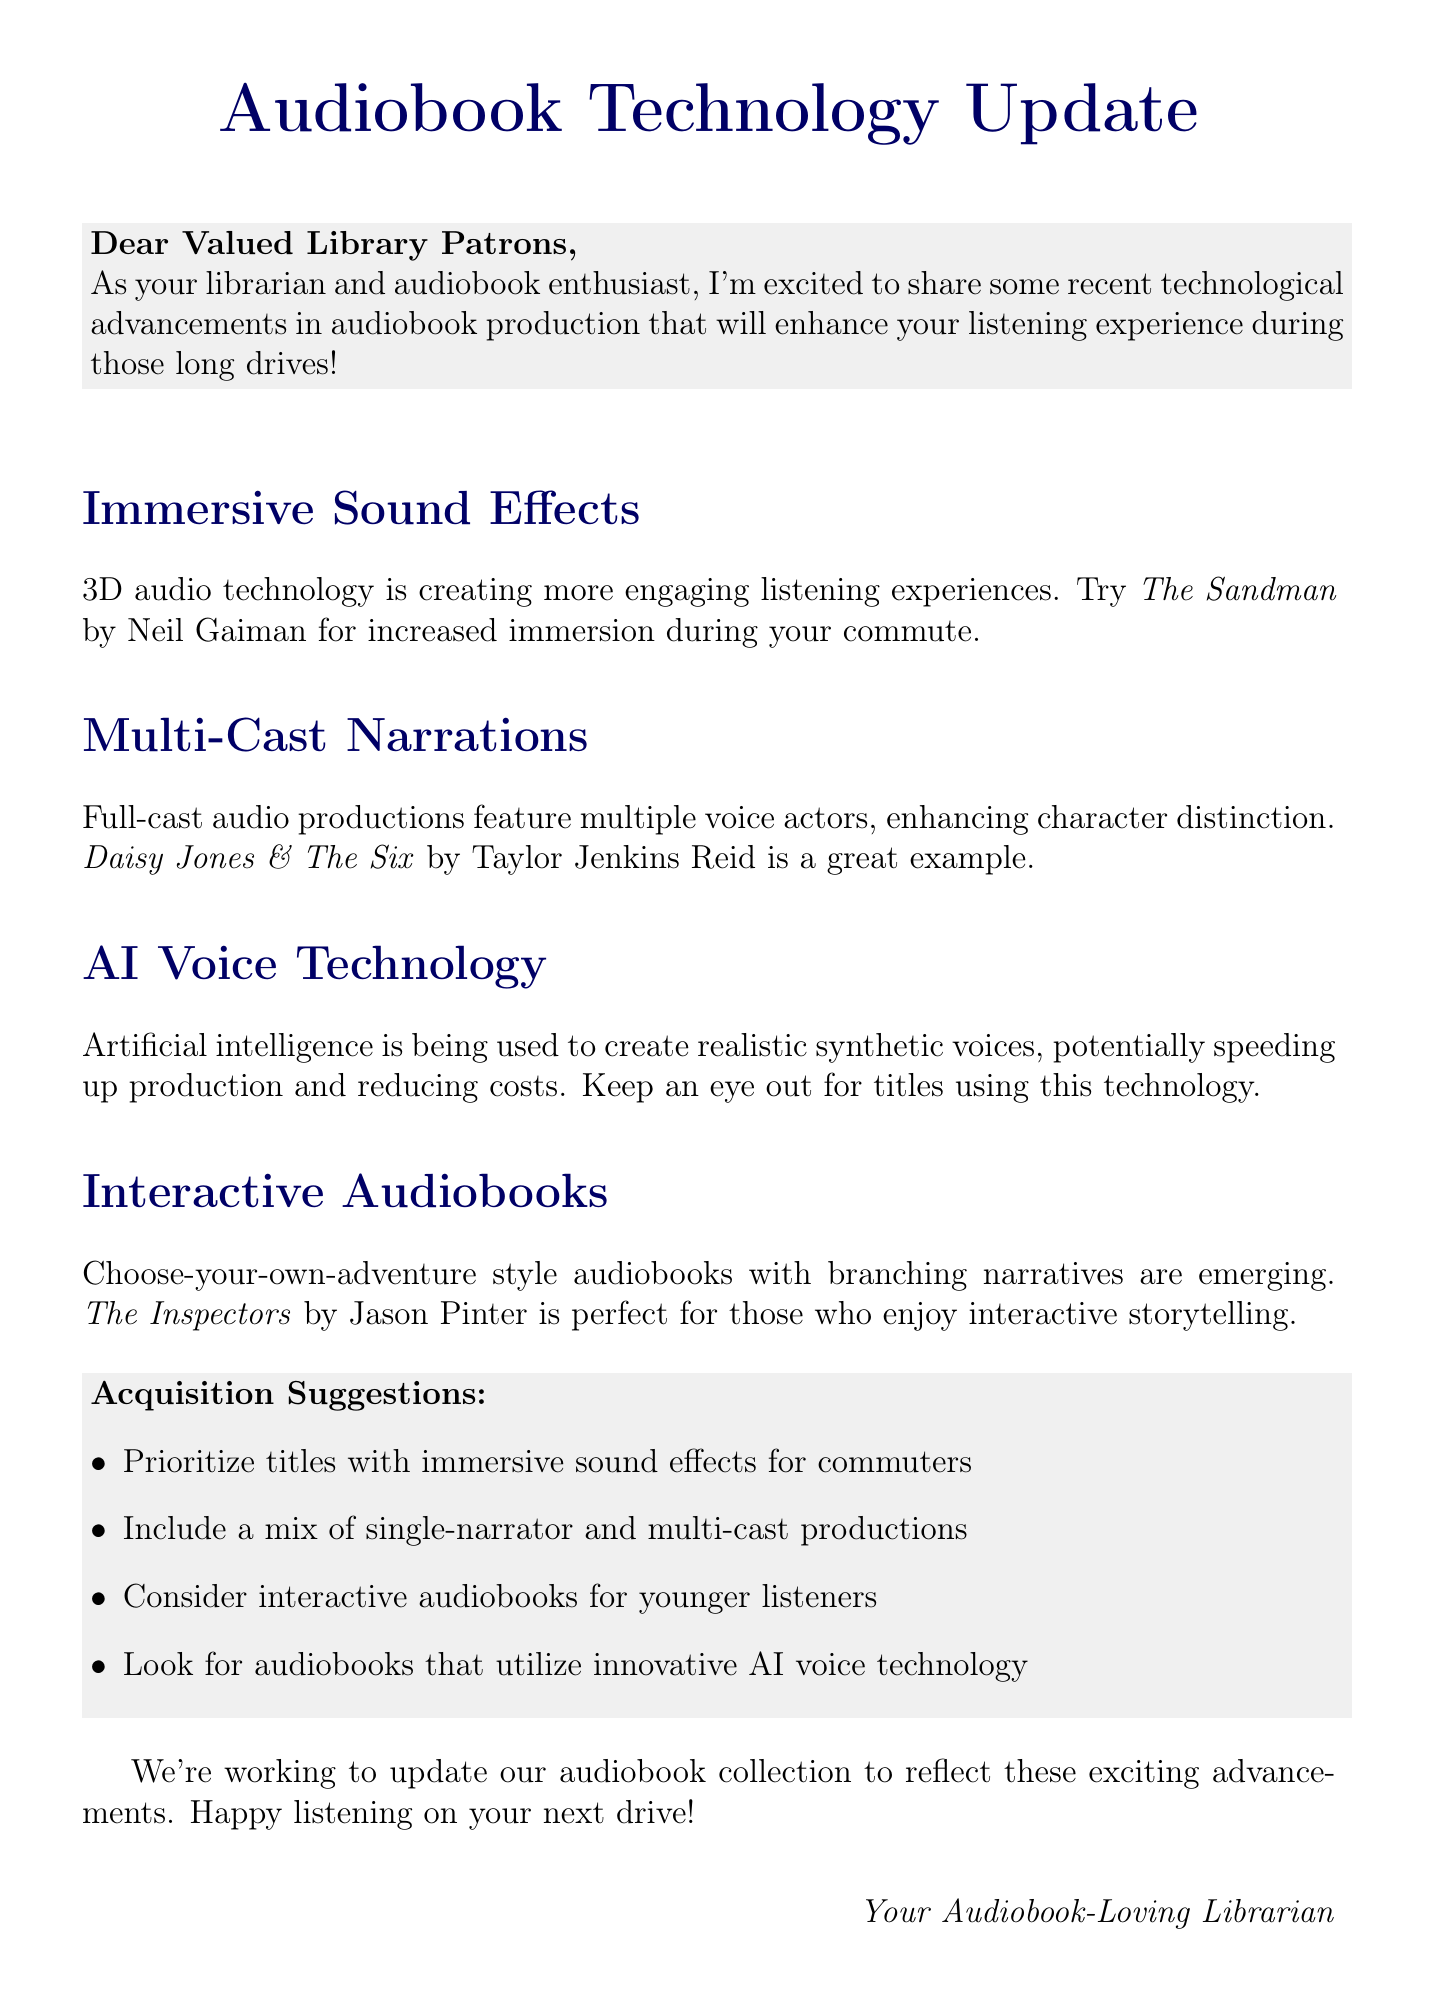What is the main topic discussed in the document? The main topic is about recent technological advancements in audiobook production.
Answer: Recent technological advancements in audiobook production Which audiobook is an example of immersive sound effects? The document provides an example of immersive sound effects with a specific audiobook title.
Answer: The Sandman by Neil Gaiman What technology is used to create realistic synthetic voices? The document mentions a specific technology employed in audiobook production.
Answer: AI voice technology What are interactive audiobooks characterized by? The document describes a specific feature of interactive audiobooks.
Answer: Choose-your-own-adventure style What is one acquisition suggestion for the library? The document lists specific suggestions for improving the library's audiobook collection.
Answer: Prioritize titles with immersive sound effects for commuters How many examples of audiobook advancements does the document provide? The document discusses several advancements, which can be counted.
Answer: Four What is the benefit of multi-cast narrations mentioned? The document discusses the advantages of using multi-cast narrations in audiobooks.
Answer: Enhanced character distinction and storytelling depth What is the action item for the library according to the document? The document concludes with a specific action for the library.
Answer: Update library's audiobook collection 